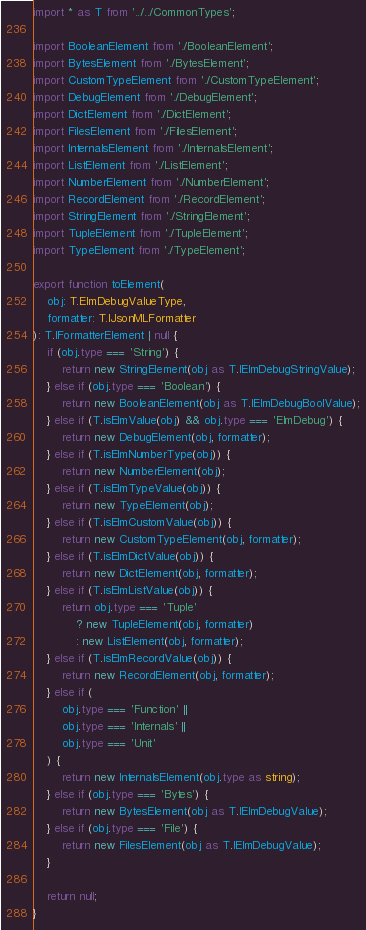<code> <loc_0><loc_0><loc_500><loc_500><_TypeScript_>import * as T from '../../CommonTypes';

import BooleanElement from './BooleanElement';
import BytesElement from './BytesElement';
import CustomTypeElement from './CustomTypeElement';
import DebugElement from './DebugElement';
import DictElement from './DictElement';
import FilesElement from './FilesElement';
import InternalsElement from './InternalsElement';
import ListElement from './ListElement';
import NumberElement from './NumberElement';
import RecordElement from './RecordElement';
import StringElement from './StringElement';
import TupleElement from './TupleElement';
import TypeElement from './TypeElement';

export function toElement(
    obj: T.ElmDebugValueType,
    formatter: T.IJsonMLFormatter
): T.IFormatterElement | null {
    if (obj.type === 'String') {
        return new StringElement(obj as T.IElmDebugStringValue);
    } else if (obj.type === 'Boolean') {
        return new BooleanElement(obj as T.IElmDebugBoolValue);
    } else if (T.isElmValue(obj) && obj.type === 'ElmDebug') {
        return new DebugElement(obj, formatter);
    } else if (T.isElmNumberType(obj)) {
        return new NumberElement(obj);
    } else if (T.isElmTypeValue(obj)) {
        return new TypeElement(obj);
    } else if (T.isElmCustomValue(obj)) {
        return new CustomTypeElement(obj, formatter);
    } else if (T.isElmDictValue(obj)) {
        return new DictElement(obj, formatter);
    } else if (T.isElmListValue(obj)) {
        return obj.type === 'Tuple'
            ? new TupleElement(obj, formatter)
            : new ListElement(obj, formatter);
    } else if (T.isElmRecordValue(obj)) {
        return new RecordElement(obj, formatter);
    } else if (
        obj.type === 'Function' ||
        obj.type === 'Internals' ||
        obj.type === 'Unit'
    ) {
        return new InternalsElement(obj.type as string);
    } else if (obj.type === 'Bytes') {
        return new BytesElement(obj as T.IElmDebugValue);
    } else if (obj.type === 'File') {
        return new FilesElement(obj as T.IElmDebugValue);
    }

    return null;
}
</code> 